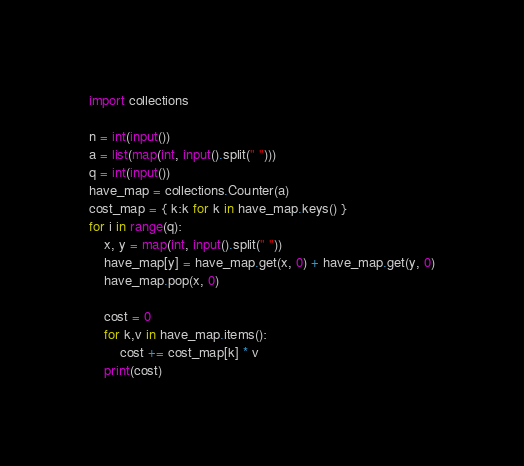<code> <loc_0><loc_0><loc_500><loc_500><_Python_>

import collections

n = int(input())
a = list(map(int, input().split(" ")))
q = int(input())
have_map = collections.Counter(a)
cost_map = { k:k for k in have_map.keys() }
for i in range(q):
    x, y = map(int, input().split(" "))
    have_map[y] = have_map.get(x, 0) + have_map.get(y, 0)
    have_map.pop(x, 0)

    cost = 0
    for k,v in have_map.items():
        cost += cost_map[k] * v
    print(cost)
</code> 